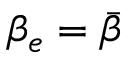Convert formula to latex. <formula><loc_0><loc_0><loc_500><loc_500>\beta _ { e } = \bar { \beta }</formula> 